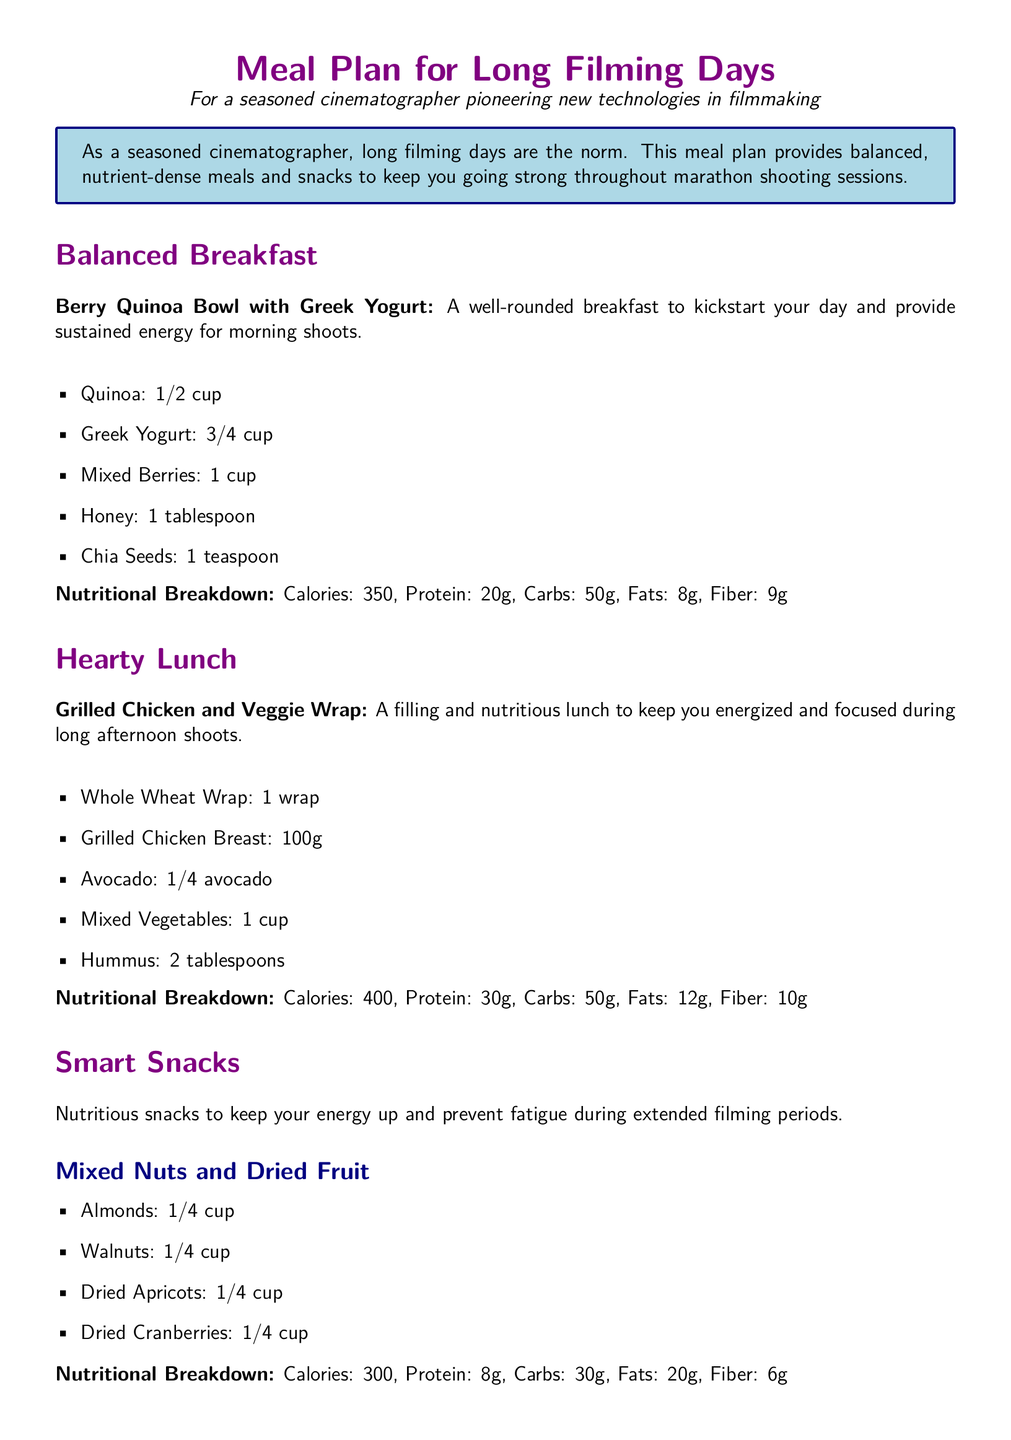What is the main purpose of the meal plan? The meal plan provides balanced, nutrient-dense meals and snacks to keep you going strong throughout marathon shooting sessions.
Answer: To keep you energized during filming How many grams of protein are in the Hearty Lunch? The Hearty Lunch includes Grilled Chicken and Veggie Wrap with a specified protein amount, which is 30 grams.
Answer: 30g What is included in the Balanced Breakfast? The Balanced Breakfast consists of ingredients including quinoa, Greek yogurt, mixed berries, honey, and chia seeds.
Answer: Berry Quinoa Bowl with Greek Yogurt How many calories are provided by the Smart Snacks? The total calories from both snack options provided in the meal plan is 300 calories for Mixed Nuts and Dried Fruit.
Answer: 300 What is the recommended daily water intake? The document specifies that at least 2 liters of water should be consumed throughout the day.
Answer: 2 liters What is a key component of the Nutritious Dinner? The Nutritious Dinner includes salmon, which is a main protein source along with quinoa and broccoli.
Answer: Salmon What is the fiber content in the Balanced Breakfast? The fiber content in the Balanced Breakfast is listed as 9 grams.
Answer: 9g Which meal is described as wise for afternoon shoots? The Hearty Lunch is described specifically for sustaining energy during afternoon shoots.
Answer: Grilled Chicken and Veggie Wrap What type of wrap is used in the lunch? The lunch utilizes a whole wheat wrap, which is mentioned as an essential ingredient.
Answer: Whole Wheat Wrap 